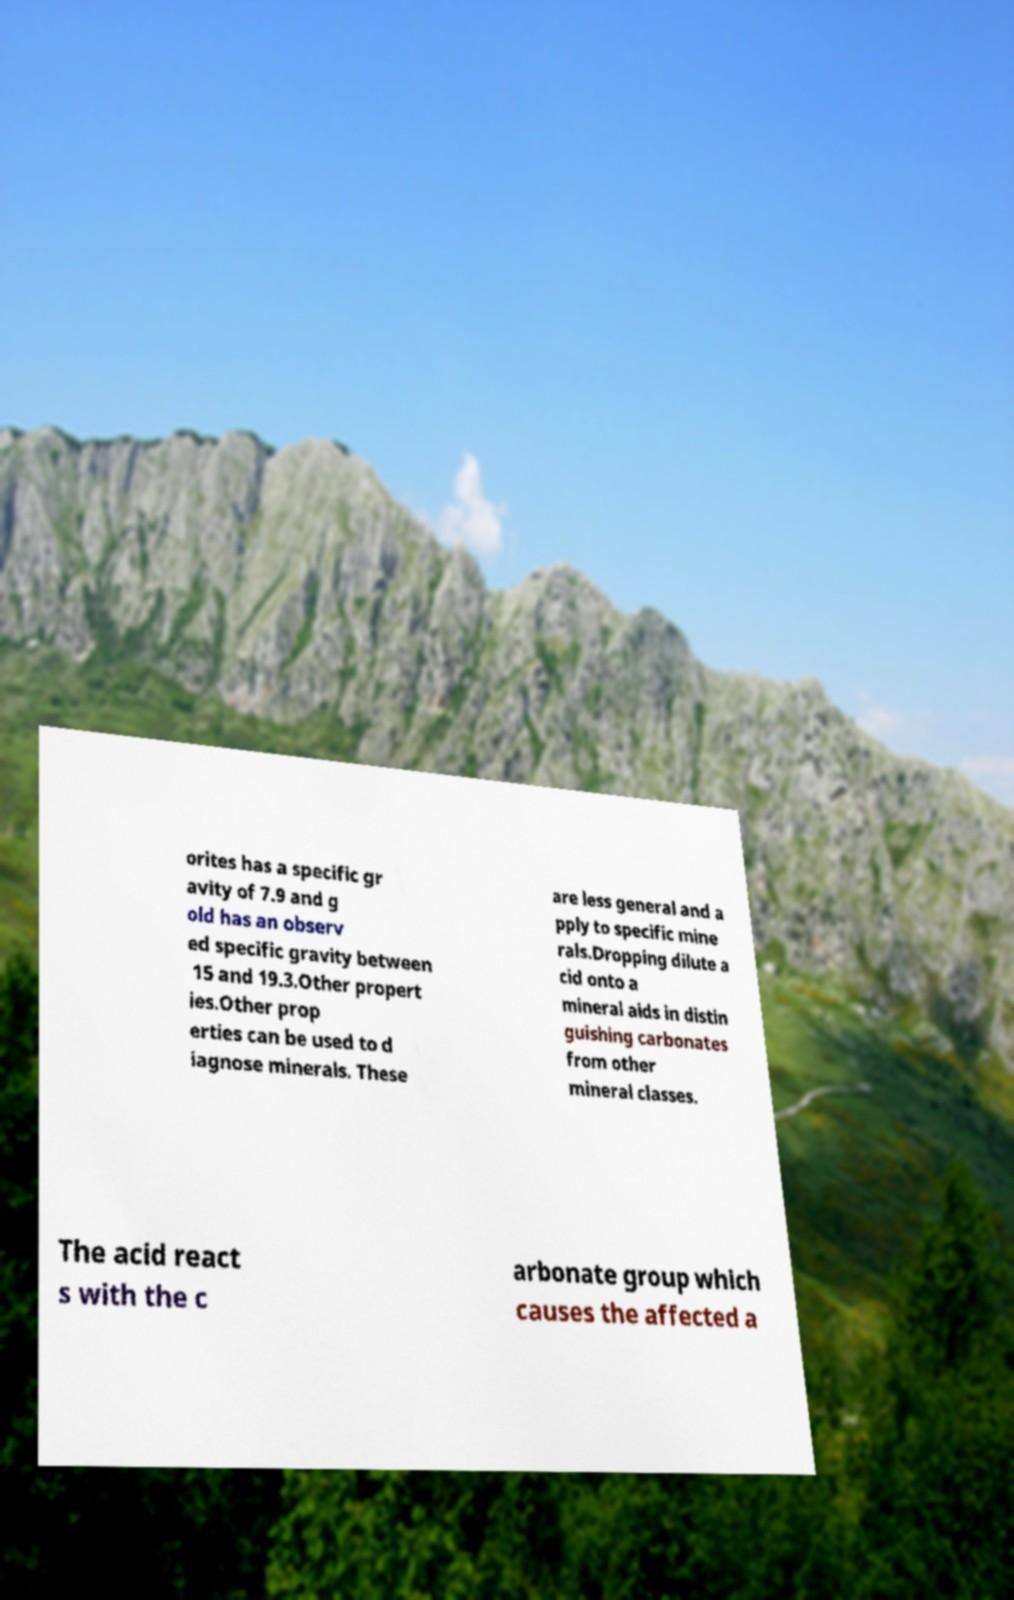Could you assist in decoding the text presented in this image and type it out clearly? orites has a specific gr avity of 7.9 and g old has an observ ed specific gravity between 15 and 19.3.Other propert ies.Other prop erties can be used to d iagnose minerals. These are less general and a pply to specific mine rals.Dropping dilute a cid onto a mineral aids in distin guishing carbonates from other mineral classes. The acid react s with the c arbonate group which causes the affected a 